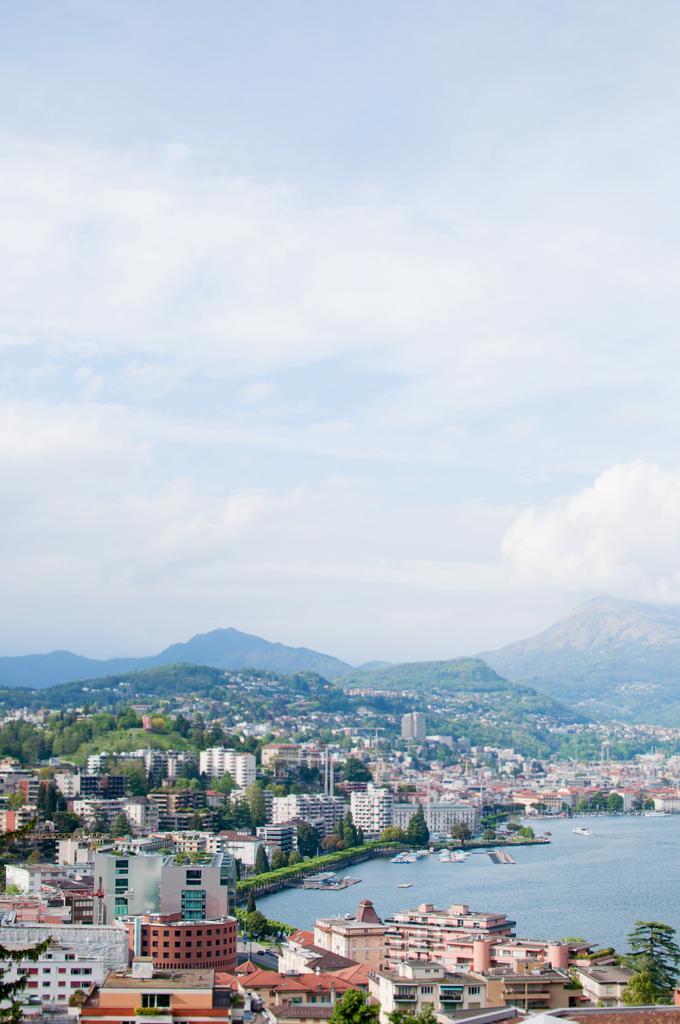Please provide a concise description of this image. In this image I can see there are houses and buildings, on the right side it is the pond. At the top it is the it is the cloudy sky. 